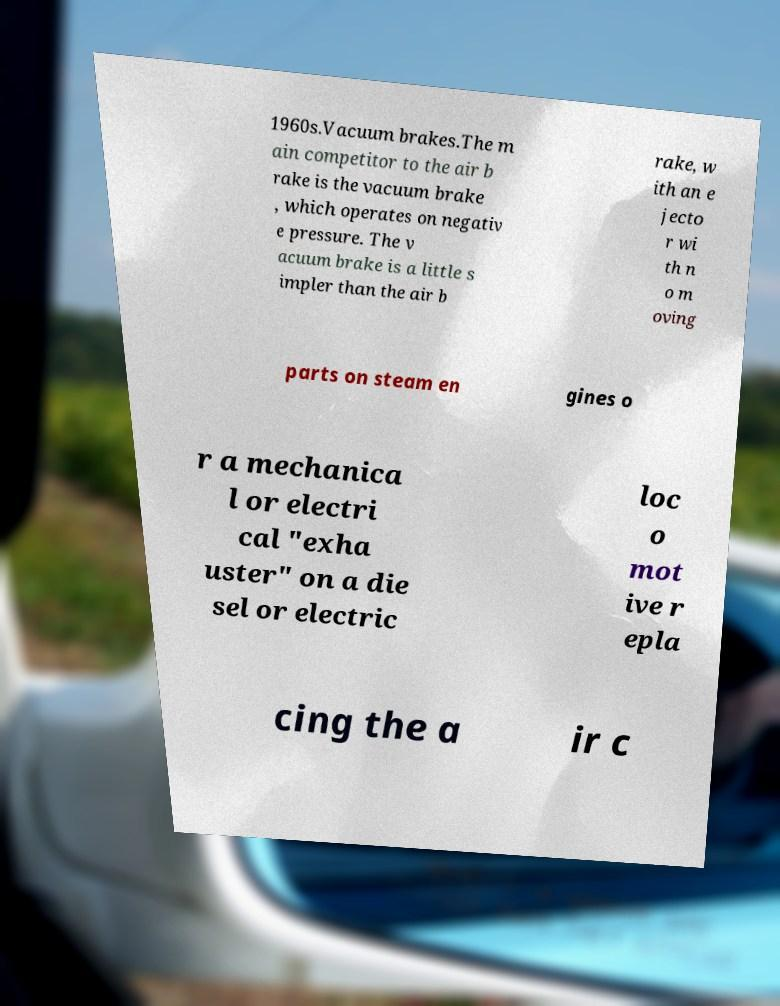For documentation purposes, I need the text within this image transcribed. Could you provide that? 1960s.Vacuum brakes.The m ain competitor to the air b rake is the vacuum brake , which operates on negativ e pressure. The v acuum brake is a little s impler than the air b rake, w ith an e jecto r wi th n o m oving parts on steam en gines o r a mechanica l or electri cal "exha uster" on a die sel or electric loc o mot ive r epla cing the a ir c 